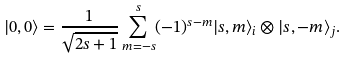<formula> <loc_0><loc_0><loc_500><loc_500>| 0 , 0 \rangle = \frac { 1 } { \sqrt { 2 s + 1 } } \sum _ { m = - s } ^ { s } ( - 1 ) ^ { s - m } | s , m \rangle _ { i } \otimes | s , - m \rangle _ { j } .</formula> 